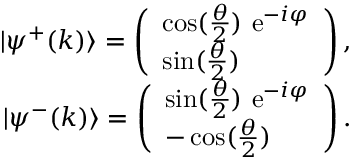Convert formula to latex. <formula><loc_0><loc_0><loc_500><loc_500>\begin{array} { r l r } & { | \psi ^ { + } ( k ) \rangle = \left ( \begin{array} { l } { \cos ( \frac { \theta } { 2 } ) e ^ { - i \varphi } } \\ { \sin ( \frac { \theta } { 2 } ) } \end{array} \right ) , } \\ & { | \psi ^ { - } ( k ) \rangle = \left ( \begin{array} { l } { \sin ( \frac { \theta } { 2 } ) e ^ { - i \varphi } } \\ { - \cos ( \frac { \theta } { 2 } ) } \end{array} \right ) . } \end{array}</formula> 